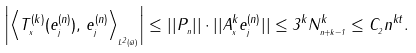Convert formula to latex. <formula><loc_0><loc_0><loc_500><loc_500>\left | \left \langle T _ { _ { x } } ^ { ( k ) } ( e _ { _ { j } } ^ { ( n ) } ) , \, e _ { _ { j } } ^ { ( n ) } \right \rangle _ { _ { L ^ { 2 } ( \varpi ) } } \right | \leq | | P _ { _ { n } } | | \cdot | | A _ { _ { x } } ^ { k } e _ { _ { j } } ^ { ( n ) } | | \leq 3 ^ { k } N _ { _ { n + k - 1 } } ^ { k } \leq C _ { _ { 2 } } n ^ { k t } .</formula> 